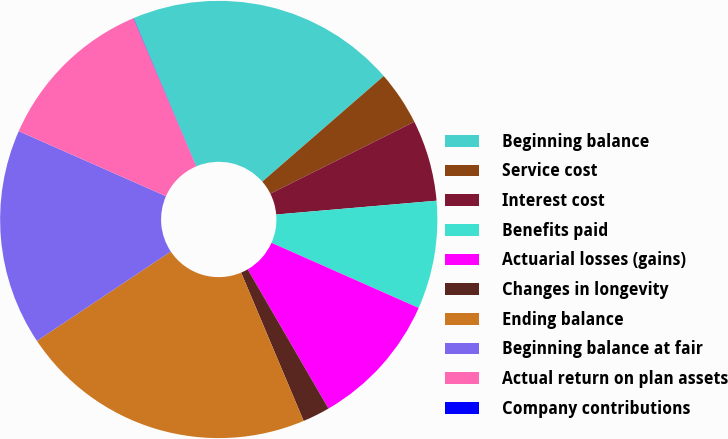Convert chart. <chart><loc_0><loc_0><loc_500><loc_500><pie_chart><fcel>Beginning balance<fcel>Service cost<fcel>Interest cost<fcel>Benefits paid<fcel>Actuarial losses (gains)<fcel>Changes in longevity<fcel>Ending balance<fcel>Beginning balance at fair<fcel>Actual return on plan assets<fcel>Company contributions<nl><fcel>19.98%<fcel>4.01%<fcel>6.01%<fcel>8.0%<fcel>10.0%<fcel>2.02%<fcel>21.98%<fcel>15.99%<fcel>12.0%<fcel>0.02%<nl></chart> 